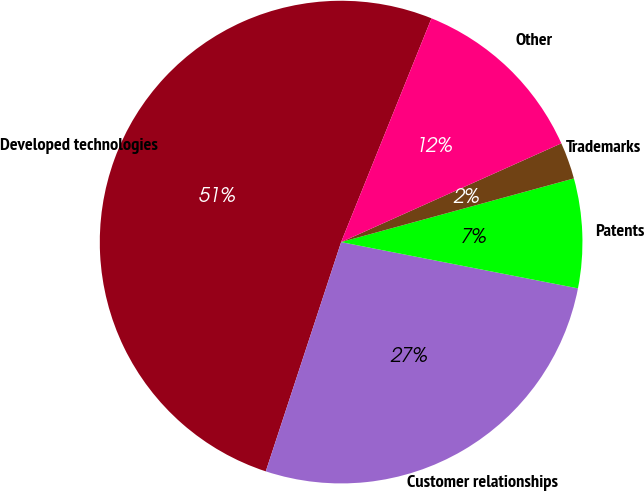<chart> <loc_0><loc_0><loc_500><loc_500><pie_chart><fcel>Developed technologies<fcel>Customer relationships<fcel>Patents<fcel>Trademarks<fcel>Other<nl><fcel>51.05%<fcel>26.98%<fcel>7.32%<fcel>2.46%<fcel>12.18%<nl></chart> 